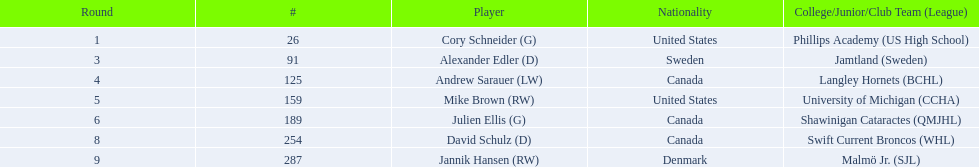What players hold canadian nationality? Andrew Sarauer (LW), Julien Ellis (G), David Schulz (D). From those, who joined langley hornets? Andrew Sarauer (LW). 